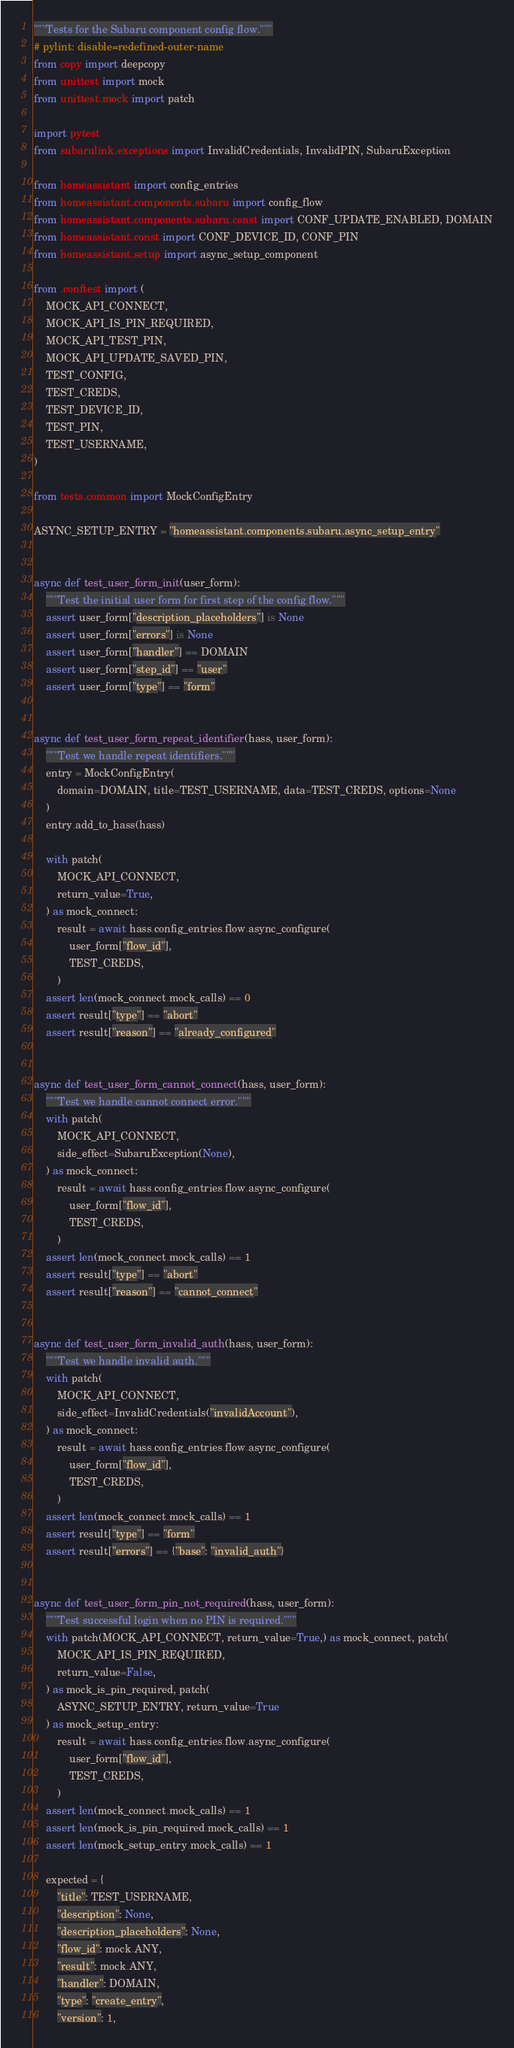Convert code to text. <code><loc_0><loc_0><loc_500><loc_500><_Python_>"""Tests for the Subaru component config flow."""
# pylint: disable=redefined-outer-name
from copy import deepcopy
from unittest import mock
from unittest.mock import patch

import pytest
from subarulink.exceptions import InvalidCredentials, InvalidPIN, SubaruException

from homeassistant import config_entries
from homeassistant.components.subaru import config_flow
from homeassistant.components.subaru.const import CONF_UPDATE_ENABLED, DOMAIN
from homeassistant.const import CONF_DEVICE_ID, CONF_PIN
from homeassistant.setup import async_setup_component

from .conftest import (
    MOCK_API_CONNECT,
    MOCK_API_IS_PIN_REQUIRED,
    MOCK_API_TEST_PIN,
    MOCK_API_UPDATE_SAVED_PIN,
    TEST_CONFIG,
    TEST_CREDS,
    TEST_DEVICE_ID,
    TEST_PIN,
    TEST_USERNAME,
)

from tests.common import MockConfigEntry

ASYNC_SETUP_ENTRY = "homeassistant.components.subaru.async_setup_entry"


async def test_user_form_init(user_form):
    """Test the initial user form for first step of the config flow."""
    assert user_form["description_placeholders"] is None
    assert user_form["errors"] is None
    assert user_form["handler"] == DOMAIN
    assert user_form["step_id"] == "user"
    assert user_form["type"] == "form"


async def test_user_form_repeat_identifier(hass, user_form):
    """Test we handle repeat identifiers."""
    entry = MockConfigEntry(
        domain=DOMAIN, title=TEST_USERNAME, data=TEST_CREDS, options=None
    )
    entry.add_to_hass(hass)

    with patch(
        MOCK_API_CONNECT,
        return_value=True,
    ) as mock_connect:
        result = await hass.config_entries.flow.async_configure(
            user_form["flow_id"],
            TEST_CREDS,
        )
    assert len(mock_connect.mock_calls) == 0
    assert result["type"] == "abort"
    assert result["reason"] == "already_configured"


async def test_user_form_cannot_connect(hass, user_form):
    """Test we handle cannot connect error."""
    with patch(
        MOCK_API_CONNECT,
        side_effect=SubaruException(None),
    ) as mock_connect:
        result = await hass.config_entries.flow.async_configure(
            user_form["flow_id"],
            TEST_CREDS,
        )
    assert len(mock_connect.mock_calls) == 1
    assert result["type"] == "abort"
    assert result["reason"] == "cannot_connect"


async def test_user_form_invalid_auth(hass, user_form):
    """Test we handle invalid auth."""
    with patch(
        MOCK_API_CONNECT,
        side_effect=InvalidCredentials("invalidAccount"),
    ) as mock_connect:
        result = await hass.config_entries.flow.async_configure(
            user_form["flow_id"],
            TEST_CREDS,
        )
    assert len(mock_connect.mock_calls) == 1
    assert result["type"] == "form"
    assert result["errors"] == {"base": "invalid_auth"}


async def test_user_form_pin_not_required(hass, user_form):
    """Test successful login when no PIN is required."""
    with patch(MOCK_API_CONNECT, return_value=True,) as mock_connect, patch(
        MOCK_API_IS_PIN_REQUIRED,
        return_value=False,
    ) as mock_is_pin_required, patch(
        ASYNC_SETUP_ENTRY, return_value=True
    ) as mock_setup_entry:
        result = await hass.config_entries.flow.async_configure(
            user_form["flow_id"],
            TEST_CREDS,
        )
    assert len(mock_connect.mock_calls) == 1
    assert len(mock_is_pin_required.mock_calls) == 1
    assert len(mock_setup_entry.mock_calls) == 1

    expected = {
        "title": TEST_USERNAME,
        "description": None,
        "description_placeholders": None,
        "flow_id": mock.ANY,
        "result": mock.ANY,
        "handler": DOMAIN,
        "type": "create_entry",
        "version": 1,</code> 